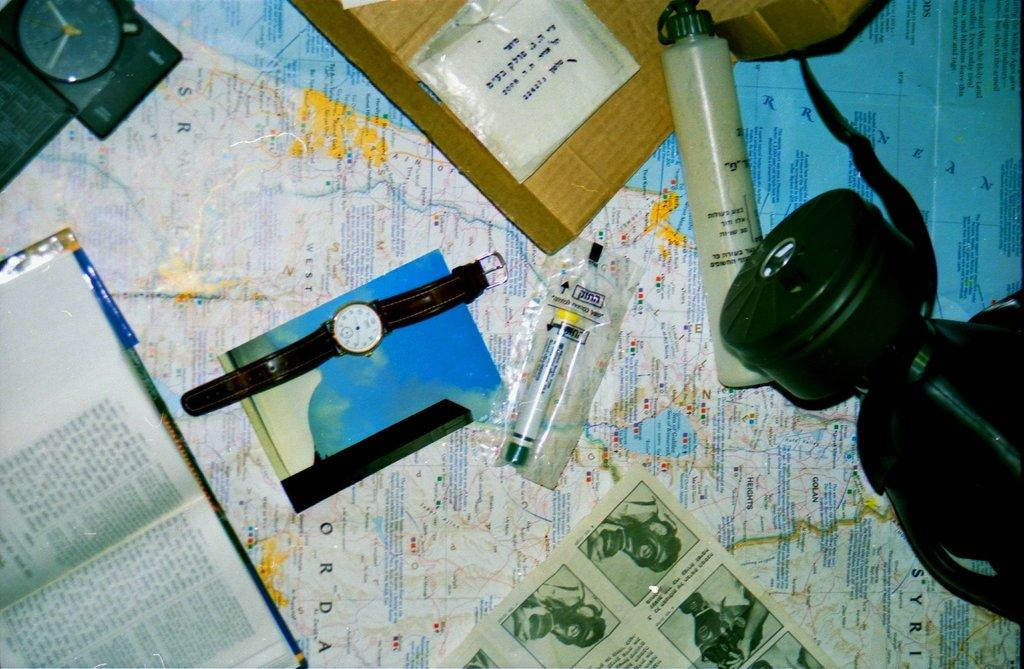What type of items are featured in the image? There are watches and a newspaper in the image. Are there any objects placed on the newspaper? No specific information is given about objects on the newspaper. However, there are objects on a map in the image. What can be seen on the map? The provided facts do not specify what is on the map, only that there are objects on it. What grade does the student receive for their performance on the bells in the image? There is no mention of bells or a student's performance in the image. 